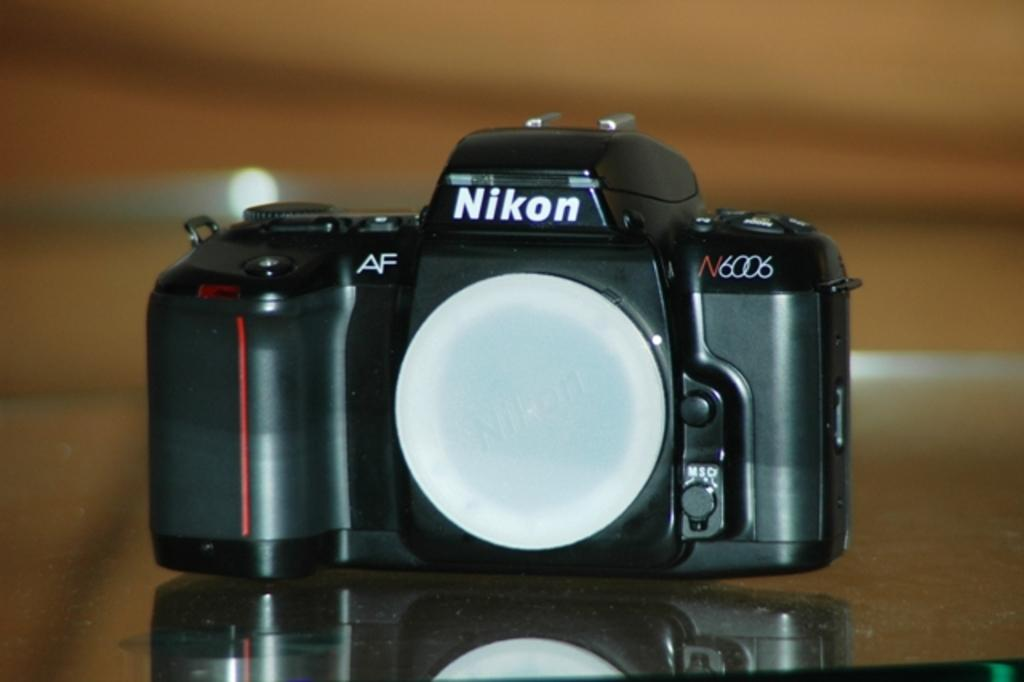<image>
Summarize the visual content of the image. A Nikon N6006 black camera with a white cap covering the lens. 